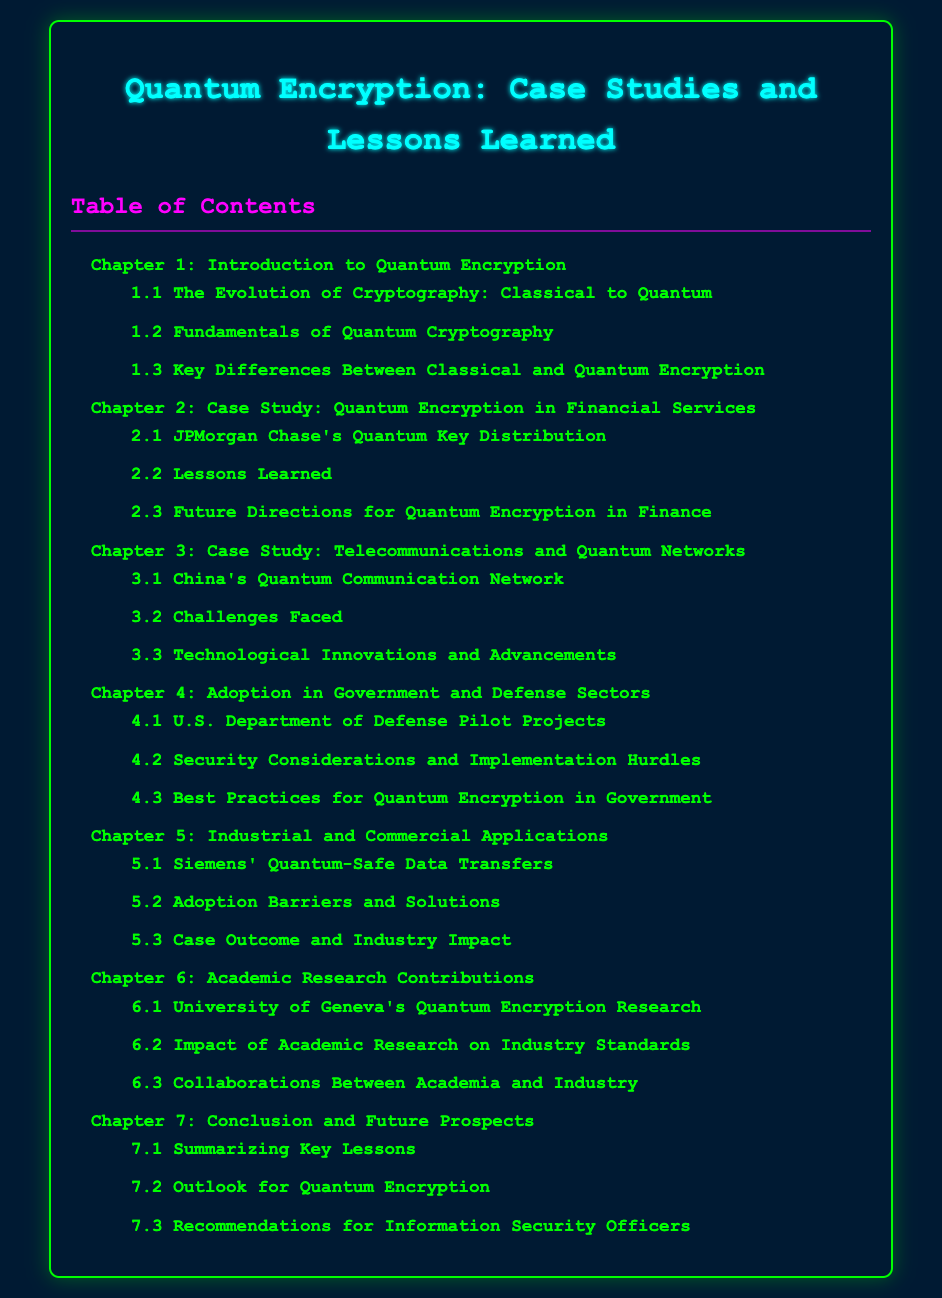What is the title of Chapter 4? Chapter 4 is labeled "Adoption in Government and Defense Sectors" in the Table of Contents.
Answer: Adoption in Government and Defense Sectors Who is involved in the case study for Chapter 2? Chapter 2 discusses "Quantum Encryption in Financial Services" with a focus on JPMorgan Chase.
Answer: JPMorgan Chase What is a key focus area in Chapter 3? Chapter 3 highlights the challenges faced in "Telecommunications and Quantum Networks."
Answer: Challenges Faced How many sections are listed under Chapter 6? Chapter 6 contains three sections related to Academic Research Contributions.
Answer: 3 What does Chapter 7 summarize? Chapter 7 contains a summary of key lessons learned in regard to Quantum Encryption.
Answer: Key Lessons What is one lesson learned mentioned in Chapter 2? Chapter 2 has a specific section titled "Lessons Learned" which emphasizes insights from deployments in financial services.
Answer: Lessons Learned 